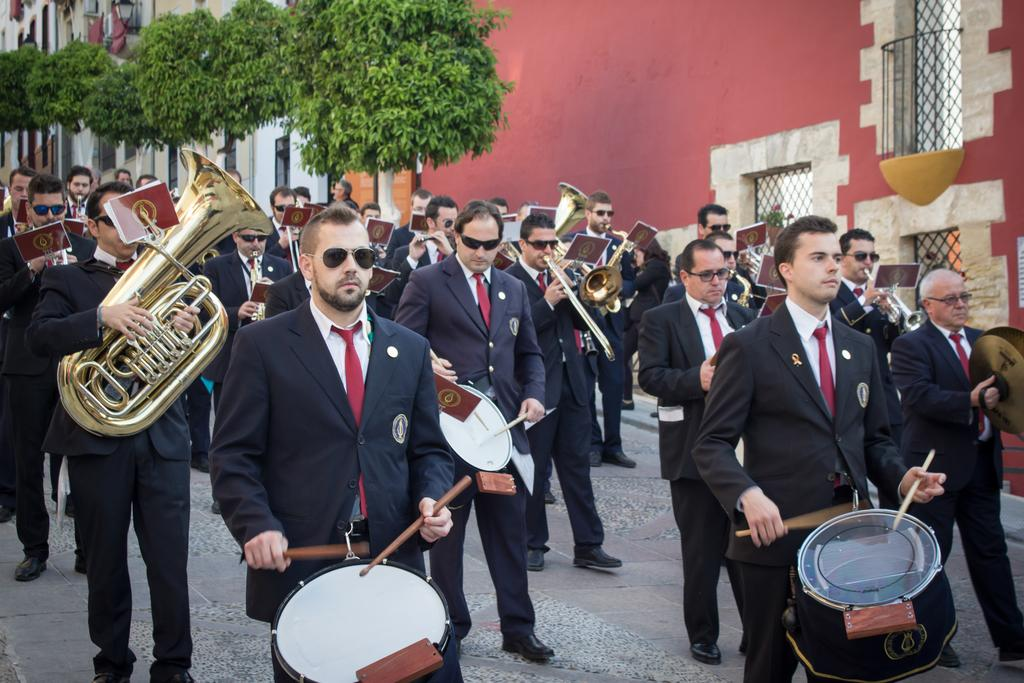What are the people in the image doing? The people in the image are walking on the ground and playing musical instruments. What can be seen in the background of the image? Buildings, a grille, and trees are visible in the background of the image. How many beggars can be seen in the image? There are no beggars present in the image. What type of industry is depicted in the image? There is no industry depicted in the image; it features people walking and playing musical instruments, as well as buildings, a grille, and trees in the background. 